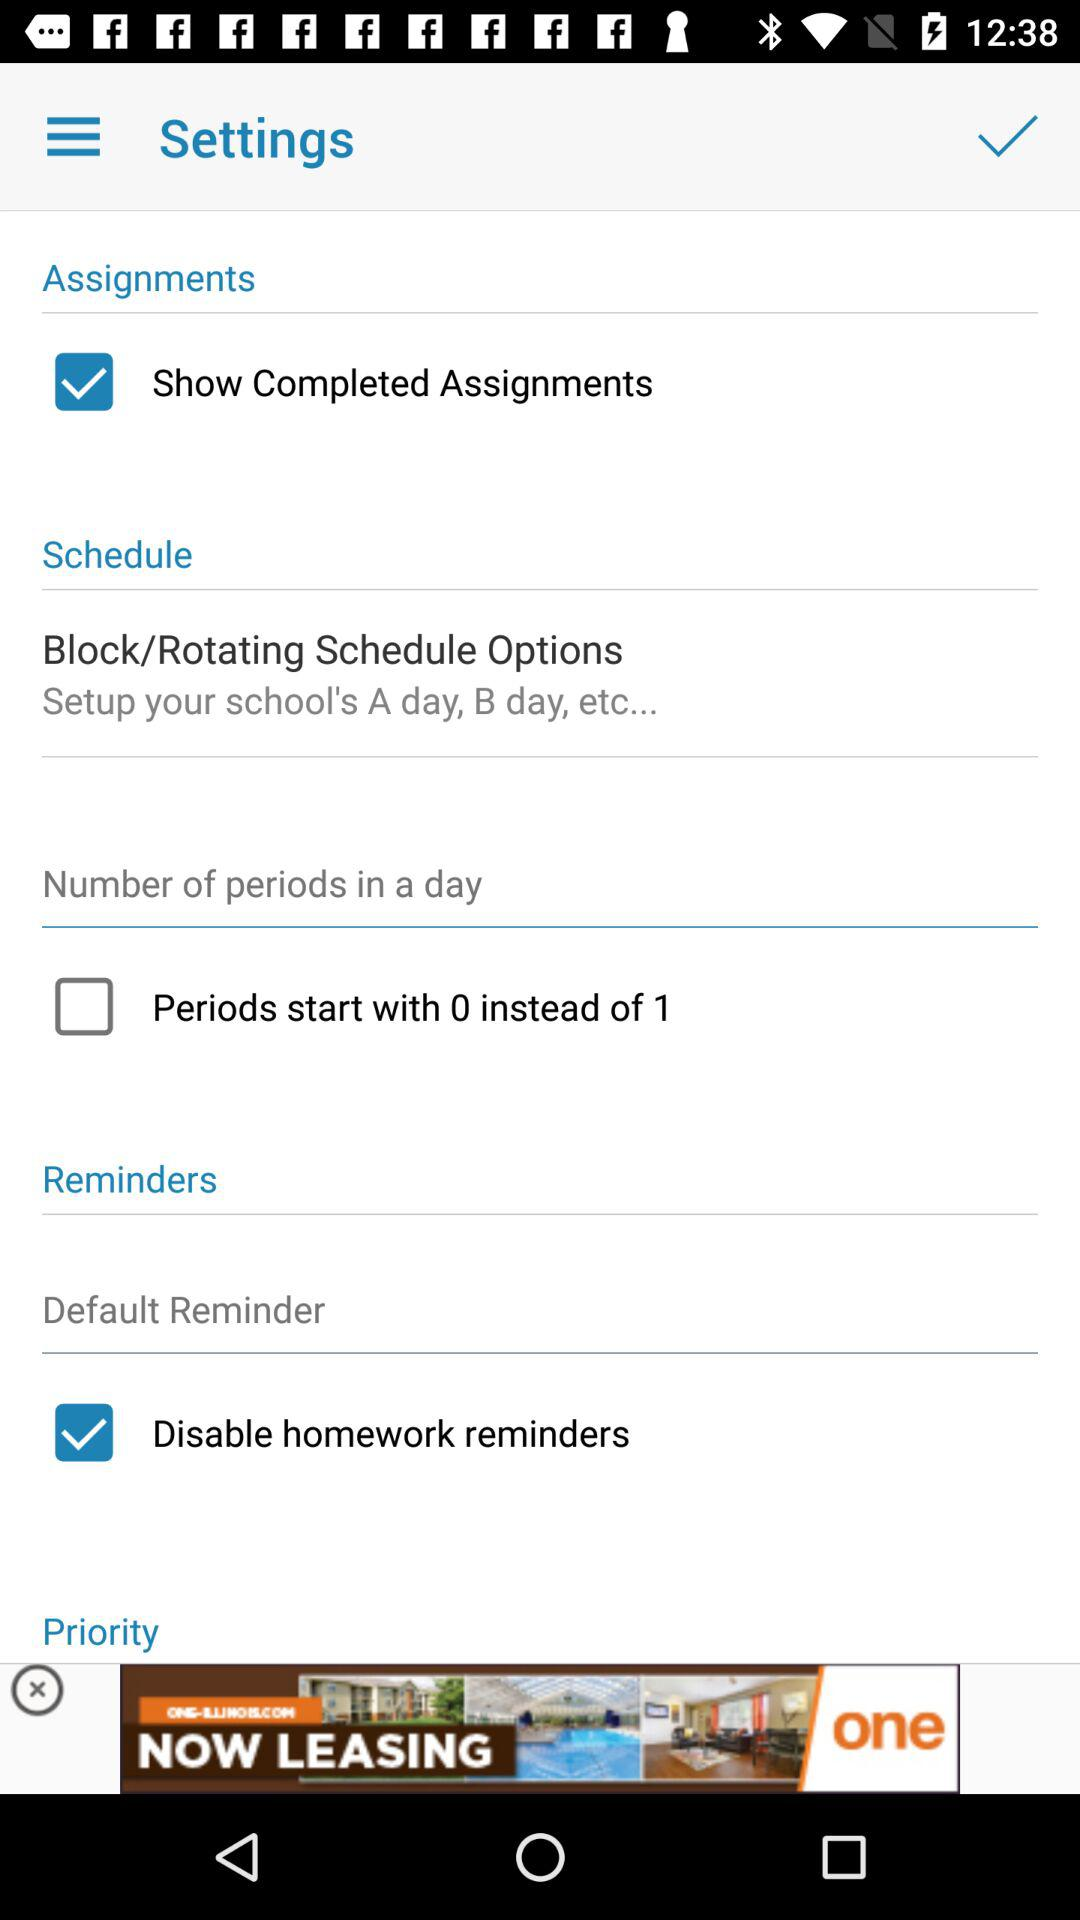What is the status of the "Disable homework reminders"? The status of the "Disable homework reminders" is "on". 